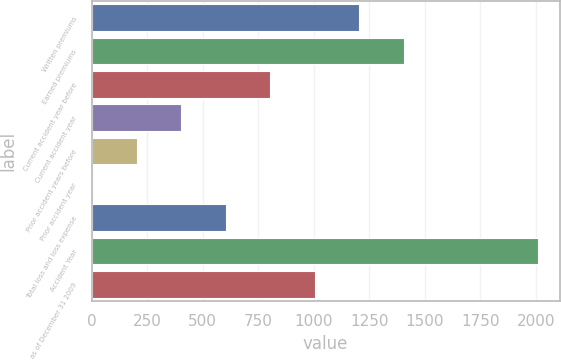Convert chart to OTSL. <chart><loc_0><loc_0><loc_500><loc_500><bar_chart><fcel>Written premiums<fcel>Earned premiums<fcel>Current accident year before<fcel>Current accident year<fcel>Prior accident years before<fcel>Prior accident year<fcel>Total loss and loss expense<fcel>Accident Year<fcel>as of December 31 2009<nl><fcel>1205.68<fcel>1406.26<fcel>804.52<fcel>403.36<fcel>202.78<fcel>2.2<fcel>603.94<fcel>2008<fcel>1005.1<nl></chart> 